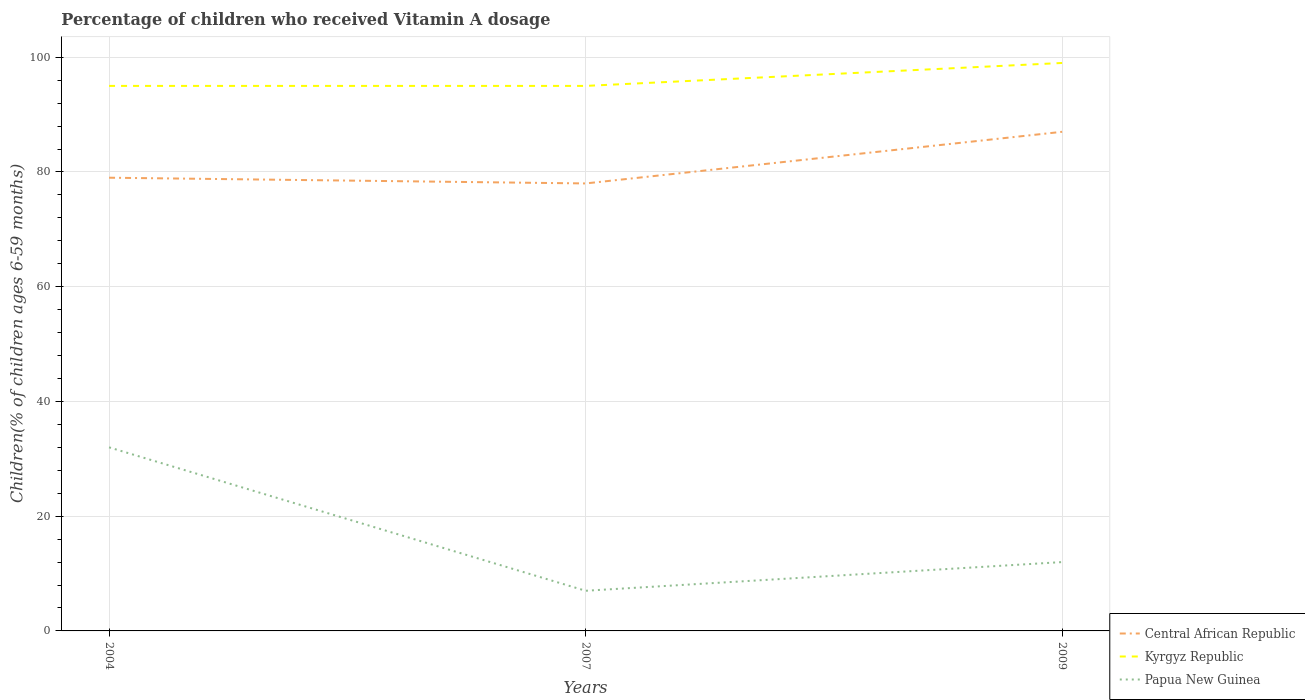How many different coloured lines are there?
Provide a short and direct response. 3. Does the line corresponding to Kyrgyz Republic intersect with the line corresponding to Papua New Guinea?
Make the answer very short. No. In which year was the percentage of children who received Vitamin A dosage in Central African Republic maximum?
Provide a succinct answer. 2007. What is the difference between the highest and the second highest percentage of children who received Vitamin A dosage in Central African Republic?
Give a very brief answer. 9. What is the difference between the highest and the lowest percentage of children who received Vitamin A dosage in Papua New Guinea?
Provide a short and direct response. 1. How many lines are there?
Make the answer very short. 3. Where does the legend appear in the graph?
Provide a short and direct response. Bottom right. How many legend labels are there?
Offer a very short reply. 3. How are the legend labels stacked?
Keep it short and to the point. Vertical. What is the title of the graph?
Provide a succinct answer. Percentage of children who received Vitamin A dosage. What is the label or title of the Y-axis?
Your answer should be very brief. Children(% of children ages 6-59 months). What is the Children(% of children ages 6-59 months) in Central African Republic in 2004?
Offer a very short reply. 79. What is the Children(% of children ages 6-59 months) in Papua New Guinea in 2004?
Keep it short and to the point. 32. What is the Children(% of children ages 6-59 months) of Kyrgyz Republic in 2009?
Provide a short and direct response. 99. What is the Children(% of children ages 6-59 months) of Papua New Guinea in 2009?
Offer a very short reply. 12. Across all years, what is the maximum Children(% of children ages 6-59 months) of Central African Republic?
Offer a very short reply. 87. Across all years, what is the maximum Children(% of children ages 6-59 months) of Papua New Guinea?
Offer a terse response. 32. Across all years, what is the minimum Children(% of children ages 6-59 months) of Kyrgyz Republic?
Make the answer very short. 95. What is the total Children(% of children ages 6-59 months) in Central African Republic in the graph?
Offer a very short reply. 244. What is the total Children(% of children ages 6-59 months) in Kyrgyz Republic in the graph?
Keep it short and to the point. 289. What is the difference between the Children(% of children ages 6-59 months) of Central African Republic in 2004 and that in 2009?
Ensure brevity in your answer.  -8. What is the difference between the Children(% of children ages 6-59 months) in Kyrgyz Republic in 2004 and that in 2009?
Ensure brevity in your answer.  -4. What is the difference between the Children(% of children ages 6-59 months) in Papua New Guinea in 2007 and that in 2009?
Provide a succinct answer. -5. What is the difference between the Children(% of children ages 6-59 months) of Kyrgyz Republic in 2004 and the Children(% of children ages 6-59 months) of Papua New Guinea in 2007?
Make the answer very short. 88. What is the difference between the Children(% of children ages 6-59 months) of Central African Republic in 2004 and the Children(% of children ages 6-59 months) of Kyrgyz Republic in 2009?
Your answer should be very brief. -20. What is the difference between the Children(% of children ages 6-59 months) in Central African Republic in 2004 and the Children(% of children ages 6-59 months) in Papua New Guinea in 2009?
Offer a very short reply. 67. What is the difference between the Children(% of children ages 6-59 months) of Kyrgyz Republic in 2004 and the Children(% of children ages 6-59 months) of Papua New Guinea in 2009?
Keep it short and to the point. 83. What is the difference between the Children(% of children ages 6-59 months) of Central African Republic in 2007 and the Children(% of children ages 6-59 months) of Papua New Guinea in 2009?
Your response must be concise. 66. What is the average Children(% of children ages 6-59 months) in Central African Republic per year?
Your answer should be very brief. 81.33. What is the average Children(% of children ages 6-59 months) in Kyrgyz Republic per year?
Your response must be concise. 96.33. In the year 2004, what is the difference between the Children(% of children ages 6-59 months) in Central African Republic and Children(% of children ages 6-59 months) in Papua New Guinea?
Your answer should be compact. 47. In the year 2004, what is the difference between the Children(% of children ages 6-59 months) of Kyrgyz Republic and Children(% of children ages 6-59 months) of Papua New Guinea?
Your answer should be very brief. 63. In the year 2007, what is the difference between the Children(% of children ages 6-59 months) in Kyrgyz Republic and Children(% of children ages 6-59 months) in Papua New Guinea?
Your response must be concise. 88. In the year 2009, what is the difference between the Children(% of children ages 6-59 months) of Central African Republic and Children(% of children ages 6-59 months) of Kyrgyz Republic?
Your response must be concise. -12. In the year 2009, what is the difference between the Children(% of children ages 6-59 months) in Central African Republic and Children(% of children ages 6-59 months) in Papua New Guinea?
Ensure brevity in your answer.  75. In the year 2009, what is the difference between the Children(% of children ages 6-59 months) of Kyrgyz Republic and Children(% of children ages 6-59 months) of Papua New Guinea?
Your answer should be compact. 87. What is the ratio of the Children(% of children ages 6-59 months) in Central African Republic in 2004 to that in 2007?
Offer a terse response. 1.01. What is the ratio of the Children(% of children ages 6-59 months) in Kyrgyz Republic in 2004 to that in 2007?
Keep it short and to the point. 1. What is the ratio of the Children(% of children ages 6-59 months) in Papua New Guinea in 2004 to that in 2007?
Ensure brevity in your answer.  4.57. What is the ratio of the Children(% of children ages 6-59 months) in Central African Republic in 2004 to that in 2009?
Your response must be concise. 0.91. What is the ratio of the Children(% of children ages 6-59 months) of Kyrgyz Republic in 2004 to that in 2009?
Give a very brief answer. 0.96. What is the ratio of the Children(% of children ages 6-59 months) of Papua New Guinea in 2004 to that in 2009?
Your answer should be compact. 2.67. What is the ratio of the Children(% of children ages 6-59 months) of Central African Republic in 2007 to that in 2009?
Provide a short and direct response. 0.9. What is the ratio of the Children(% of children ages 6-59 months) of Kyrgyz Republic in 2007 to that in 2009?
Provide a succinct answer. 0.96. What is the ratio of the Children(% of children ages 6-59 months) of Papua New Guinea in 2007 to that in 2009?
Provide a succinct answer. 0.58. What is the difference between the highest and the second highest Children(% of children ages 6-59 months) of Central African Republic?
Offer a very short reply. 8. What is the difference between the highest and the lowest Children(% of children ages 6-59 months) in Kyrgyz Republic?
Your response must be concise. 4. 